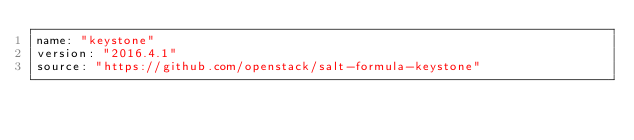Convert code to text. <code><loc_0><loc_0><loc_500><loc_500><_YAML_>name: "keystone"
version: "2016.4.1"
source: "https://github.com/openstack/salt-formula-keystone"
</code> 